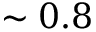<formula> <loc_0><loc_0><loc_500><loc_500>\sim 0 . 8</formula> 